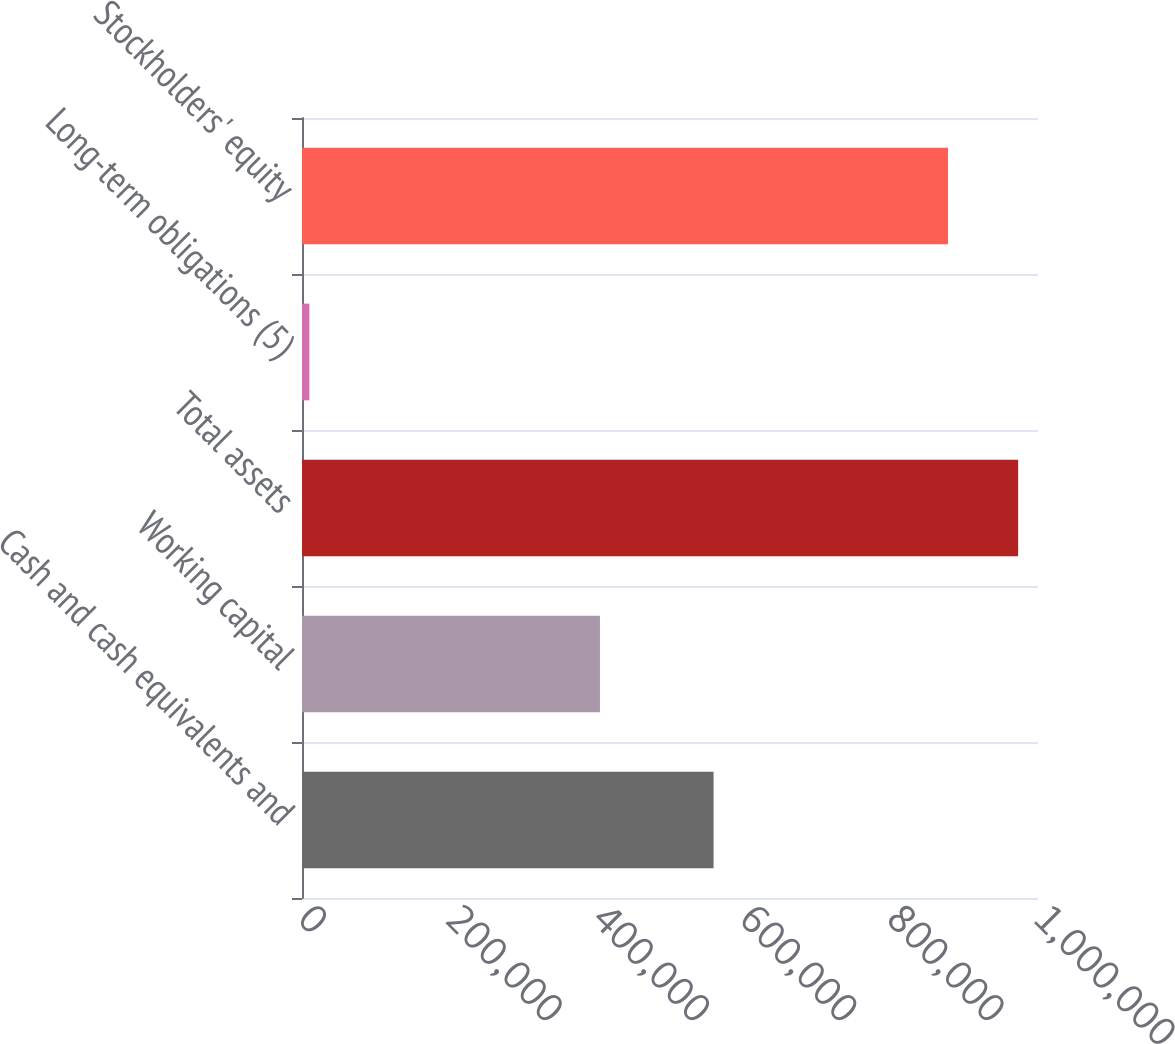Convert chart to OTSL. <chart><loc_0><loc_0><loc_500><loc_500><bar_chart><fcel>Cash and cash equivalents and<fcel>Working capital<fcel>Total assets<fcel>Long-term obligations (5)<fcel>Stockholders' equity<nl><fcel>559189<fcel>404836<fcel>972998<fcel>9969<fcel>877681<nl></chart> 